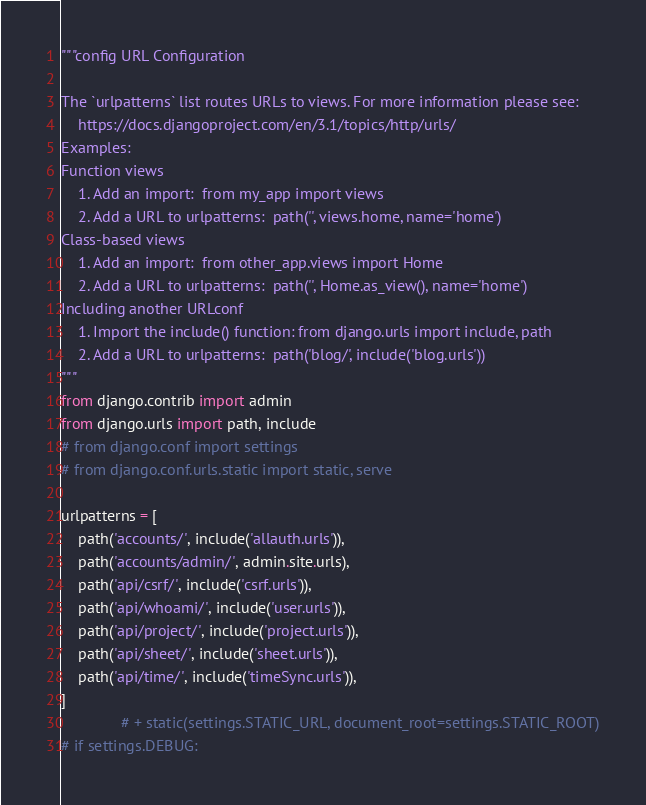<code> <loc_0><loc_0><loc_500><loc_500><_Python_>"""config URL Configuration

The `urlpatterns` list routes URLs to views. For more information please see:
    https://docs.djangoproject.com/en/3.1/topics/http/urls/
Examples:
Function views
    1. Add an import:  from my_app import views
    2. Add a URL to urlpatterns:  path('', views.home, name='home')
Class-based views
    1. Add an import:  from other_app.views import Home
    2. Add a URL to urlpatterns:  path('', Home.as_view(), name='home')
Including another URLconf
    1. Import the include() function: from django.urls import include, path
    2. Add a URL to urlpatterns:  path('blog/', include('blog.urls'))
"""
from django.contrib import admin
from django.urls import path, include
# from django.conf import settings
# from django.conf.urls.static import static, serve

urlpatterns = [
    path('accounts/', include('allauth.urls')),
    path('accounts/admin/', admin.site.urls),
    path('api/csrf/', include('csrf.urls')),
    path('api/whoami/', include('user.urls')),
    path('api/project/', include('project.urls')),
    path('api/sheet/', include('sheet.urls')),
    path('api/time/', include('timeSync.urls')),
]
              # + static(settings.STATIC_URL, document_root=settings.STATIC_ROOT)
# if settings.DEBUG:
</code> 